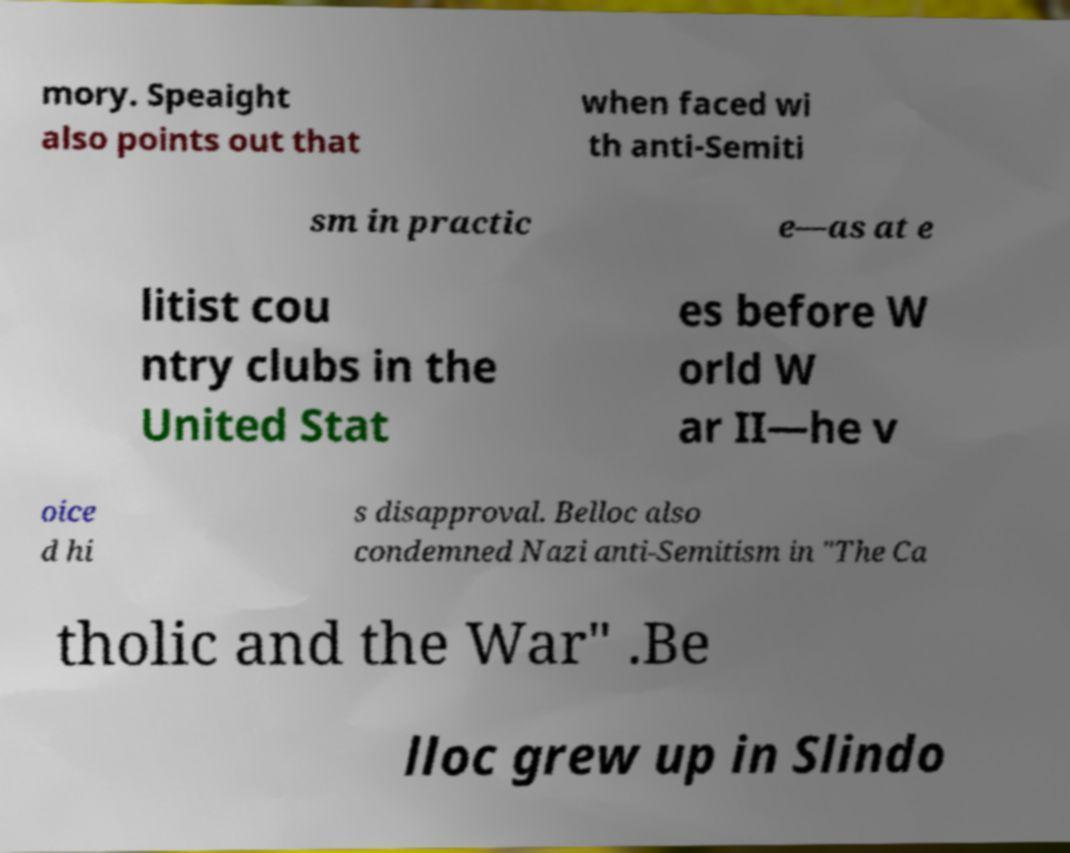There's text embedded in this image that I need extracted. Can you transcribe it verbatim? mory. Speaight also points out that when faced wi th anti-Semiti sm in practic e—as at e litist cou ntry clubs in the United Stat es before W orld W ar II—he v oice d hi s disapproval. Belloc also condemned Nazi anti-Semitism in "The Ca tholic and the War" .Be lloc grew up in Slindo 